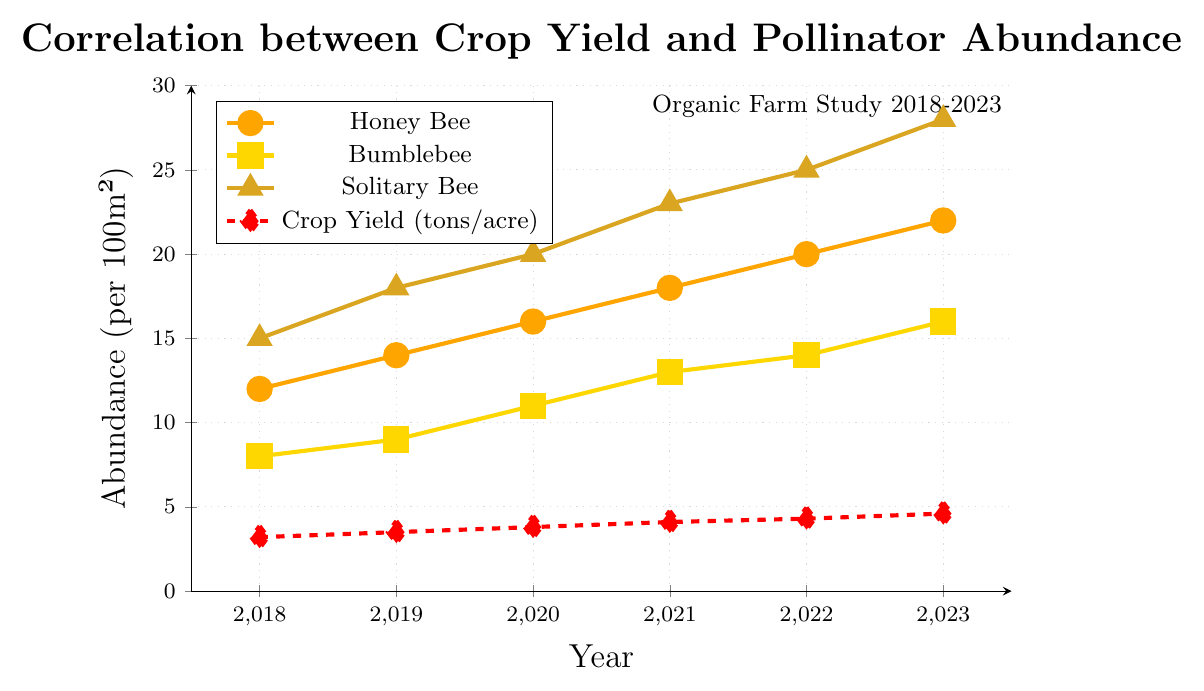What is the trend of honey bee abundance from 2018 to 2023? To determine the trend, observe the line for honey bee abundance marked with circles. The values increase from 12 to 22 over the years 2018 to 2023.
Answer: Increasing How much did crop yield increase from 2018 to 2023? Look at the red dashed line representing crop yield and note the values for 2018 and 2023. The crop yield in 2018 is 3.2 tons/acre and in 2023 is 4.6 tons/acre. The difference is 4.6 - 3.2 = 1.4 tons/acre.
Answer: 1.4 tons/acre Which pollinator had the highest abundance in 2020? Compare the y-values for honey bee (16), bumblebee (11), and solitary bee (20) in 2020. The solitary bee line, marked with triangles, has the highest value.
Answer: Solitary bee Is there a year when both honey bee and bumblebee abundances were equal? Compare the honey bee and bumblebee lines across all years. There is no year in which the abundances of honey bees and bumblebees are equal.
Answer: No By how much did the solitary bee abundance increase from 2019 to 2021? Note the values for solitary bee abundance in 2019 (18) and 2021 (23). The difference is 23 - 18 = 5.
Answer: 5 In which year does crop yield first surpass 4 tons/acre? Check the red dashed line for the first year where the crop yield value exceeds 4. The crop yield first surpasses 4 tons/acre in 2021.
Answer: 2021 During which year is the gap between honey bee abundance and bumblebee abundance the largest? Calculate the difference between honey bee and bumblebee abundances for each year. The differences are: 2018 (4), 2019 (5), 2020 (5), 2021 (5), 2022 (6), 2023 (6). The largest gap is 6 in 2022 and 2023.
Answer: 2022 and 2023 What is the average crop yield from 2018 to 2023? Sum the crop yield values for all years and divide by the number of years. (3.2 + 3.5 + 3.8 + 4.1 + 4.3 + 4.6) / 6 = 23.5 / 6 = 3.92 tons/acre.
Answer: 3.92 tons/acre Compare the slopes: Is the increase in the abundance of solitary bees steeper than that of honey bees between 2018 and 2023? Evaluate the slopes by comparing the vertical changes over the horizontal change (years) from 2018 to 2023. For honey bees, the change is (22-12)/(2023-2018) = 10/5 = 2. For solitary bees, the change is (28-15)/(2023-2018) = 13/5 = 2.6. The solitary bee slope is steeper.
Answer: Yes 